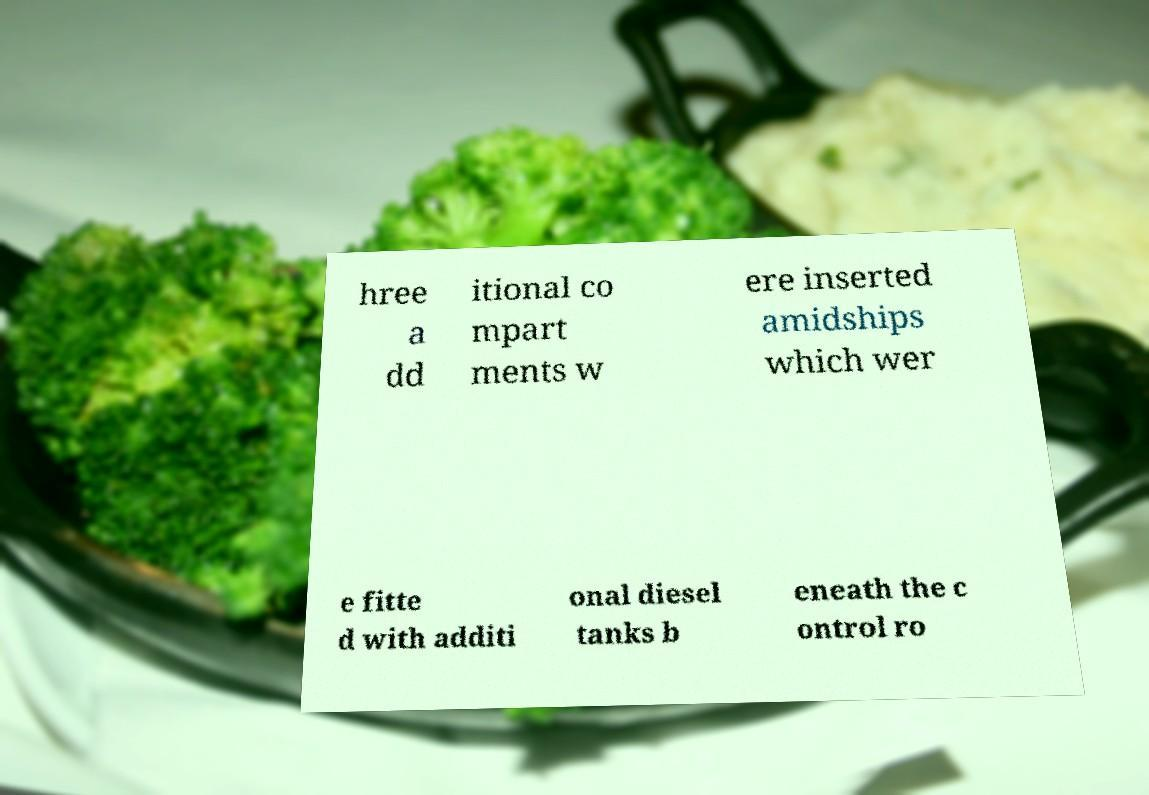For documentation purposes, I need the text within this image transcribed. Could you provide that? hree a dd itional co mpart ments w ere inserted amidships which wer e fitte d with additi onal diesel tanks b eneath the c ontrol ro 